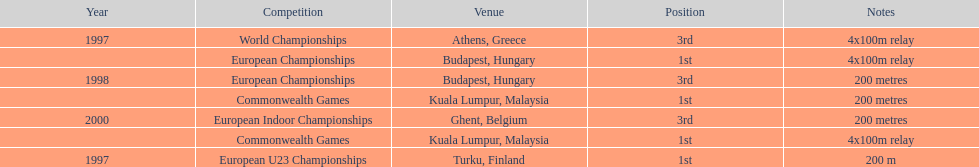During the 2000 european indoor championships, what was the distance of the sprint competition? 200 metres. 